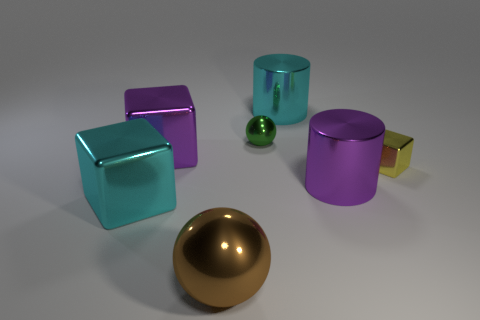What number of other things are the same color as the tiny block?
Make the answer very short. 0. Is the sphere that is in front of the small cube made of the same material as the cyan object on the left side of the tiny sphere?
Ensure brevity in your answer.  Yes. Is the number of shiny cylinders that are to the right of the tiny yellow object the same as the number of metallic things that are in front of the big cyan block?
Give a very brief answer. No. There is a block that is in front of the tiny yellow cube; what is its material?
Your response must be concise. Metal. Are there fewer green metal things than large gray metallic cylinders?
Your response must be concise. No. There is a thing that is both to the left of the large cyan metallic cylinder and right of the brown metal sphere; what shape is it?
Offer a terse response. Sphere. What number of large gray metallic objects are there?
Offer a very short reply. 0. There is a large cyan object that is in front of the yellow block; what number of large cyan objects are behind it?
Ensure brevity in your answer.  1. What color is the other metal thing that is the same shape as the tiny green metal thing?
Your answer should be very brief. Brown. Is the yellow object made of the same material as the tiny green thing?
Offer a terse response. Yes. 